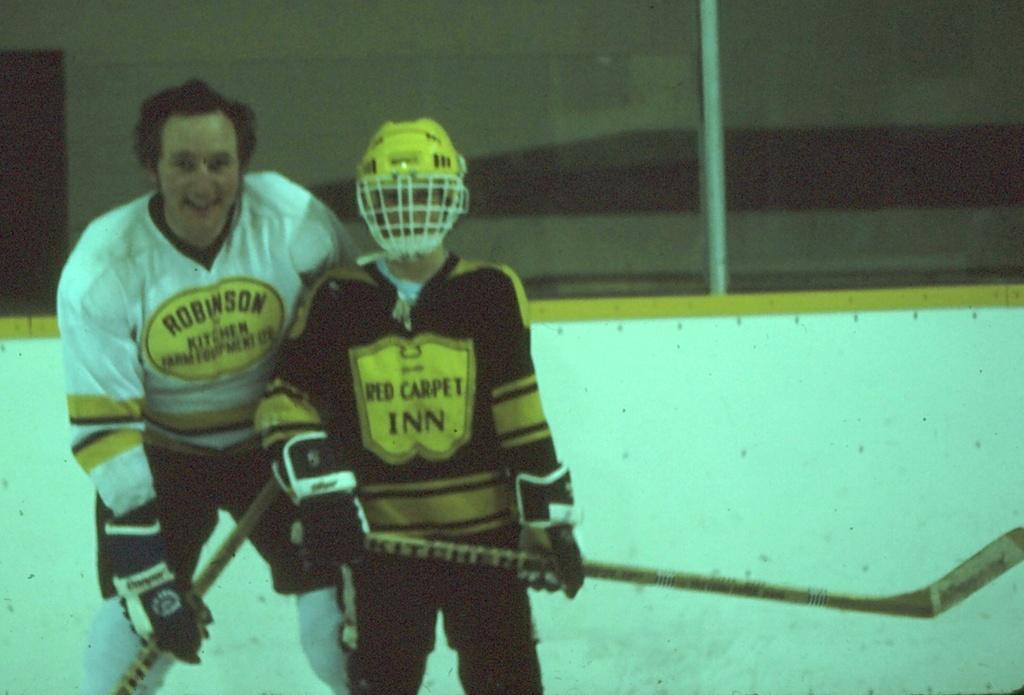How many people are in the image? There are two people in the image. What are the people doing in the image? The people are standing on a path and holding sticks. What is located behind the people in the image? There is a wall behind the people. Can you tell me how the zephyr affects the people in the image? There is no mention of a zephyr or any wind in the image, so its effect cannot be determined. 